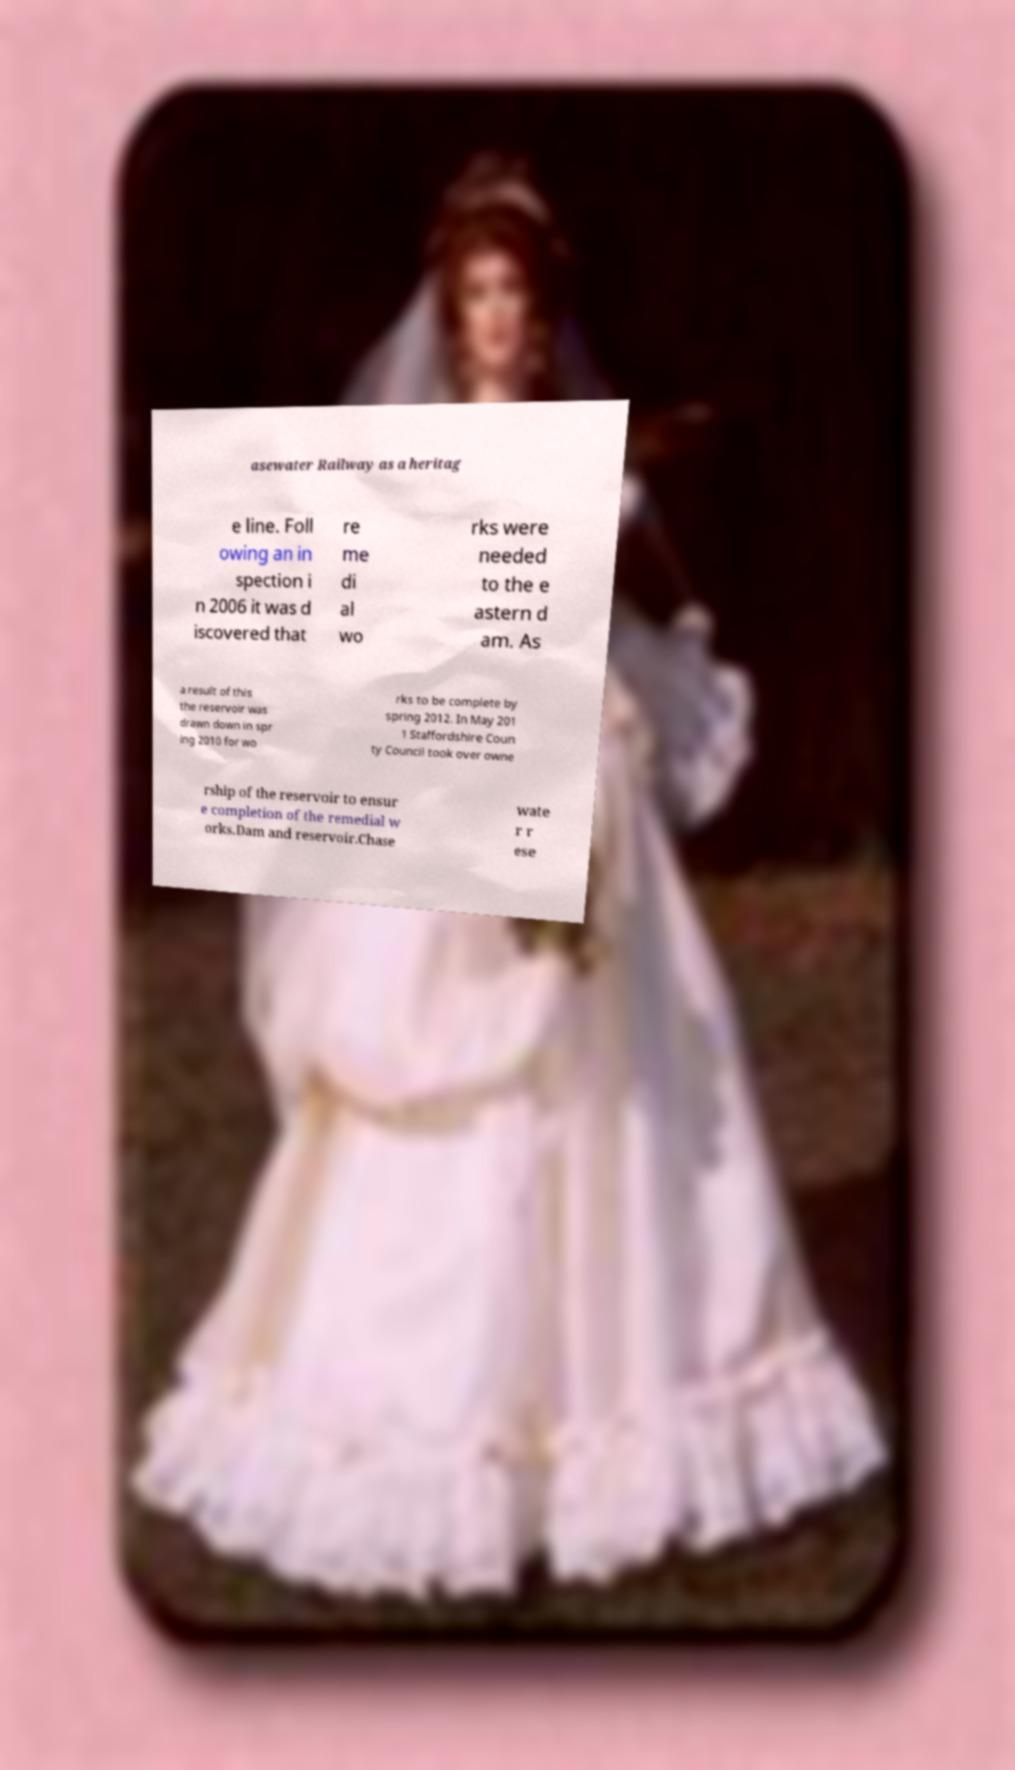Could you assist in decoding the text presented in this image and type it out clearly? asewater Railway as a heritag e line. Foll owing an in spection i n 2006 it was d iscovered that re me di al wo rks were needed to the e astern d am. As a result of this the reservoir was drawn down in spr ing 2010 for wo rks to be complete by spring 2012. In May 201 1 Staffordshire Coun ty Council took over owne rship of the reservoir to ensur e completion of the remedial w orks.Dam and reservoir.Chase wate r r ese 